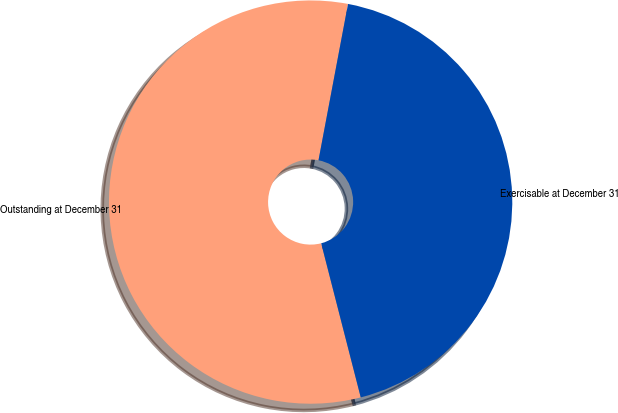Convert chart. <chart><loc_0><loc_0><loc_500><loc_500><pie_chart><fcel>Outstanding at December 31<fcel>Exercisable at December 31<nl><fcel>56.97%<fcel>43.03%<nl></chart> 